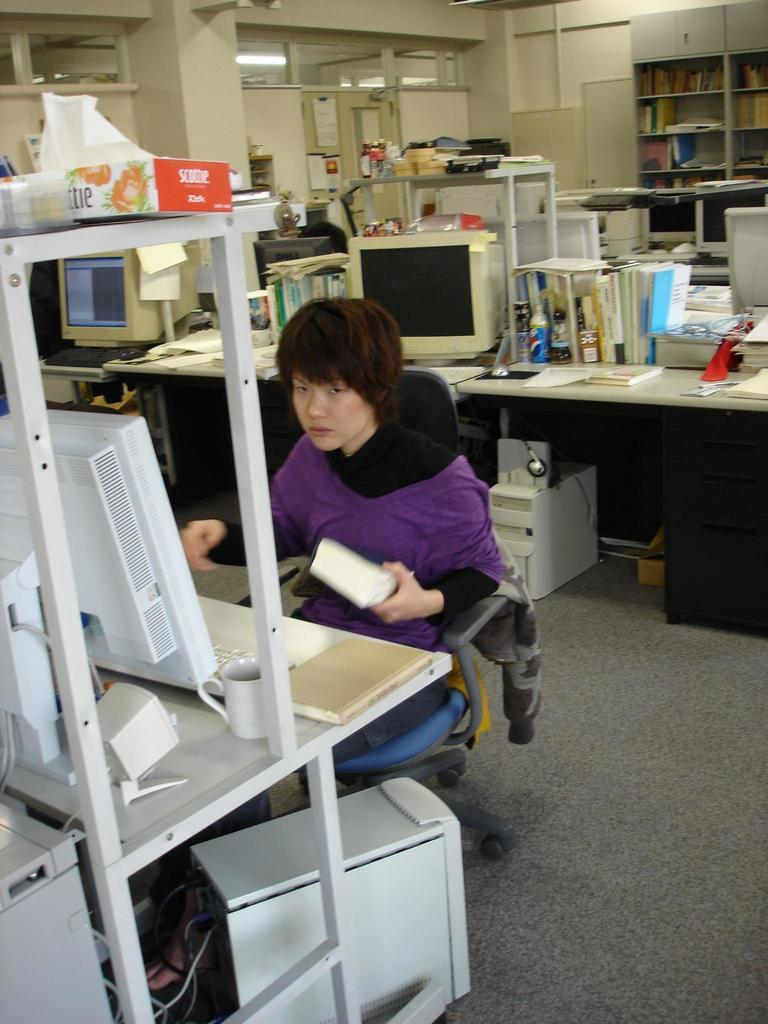Who or what is present in the image? There is a person in the image. What can be seen on the desk in the image? There are computers on the desk, as well as other objects. Can you describe the light visible at the top of the image? There is a light visible at the top of the image, but its specific characteristics are not mentioned in the facts. What type of memory can be seen in the image? There is no mention of memory in the image, so it cannot be determined from the facts. 